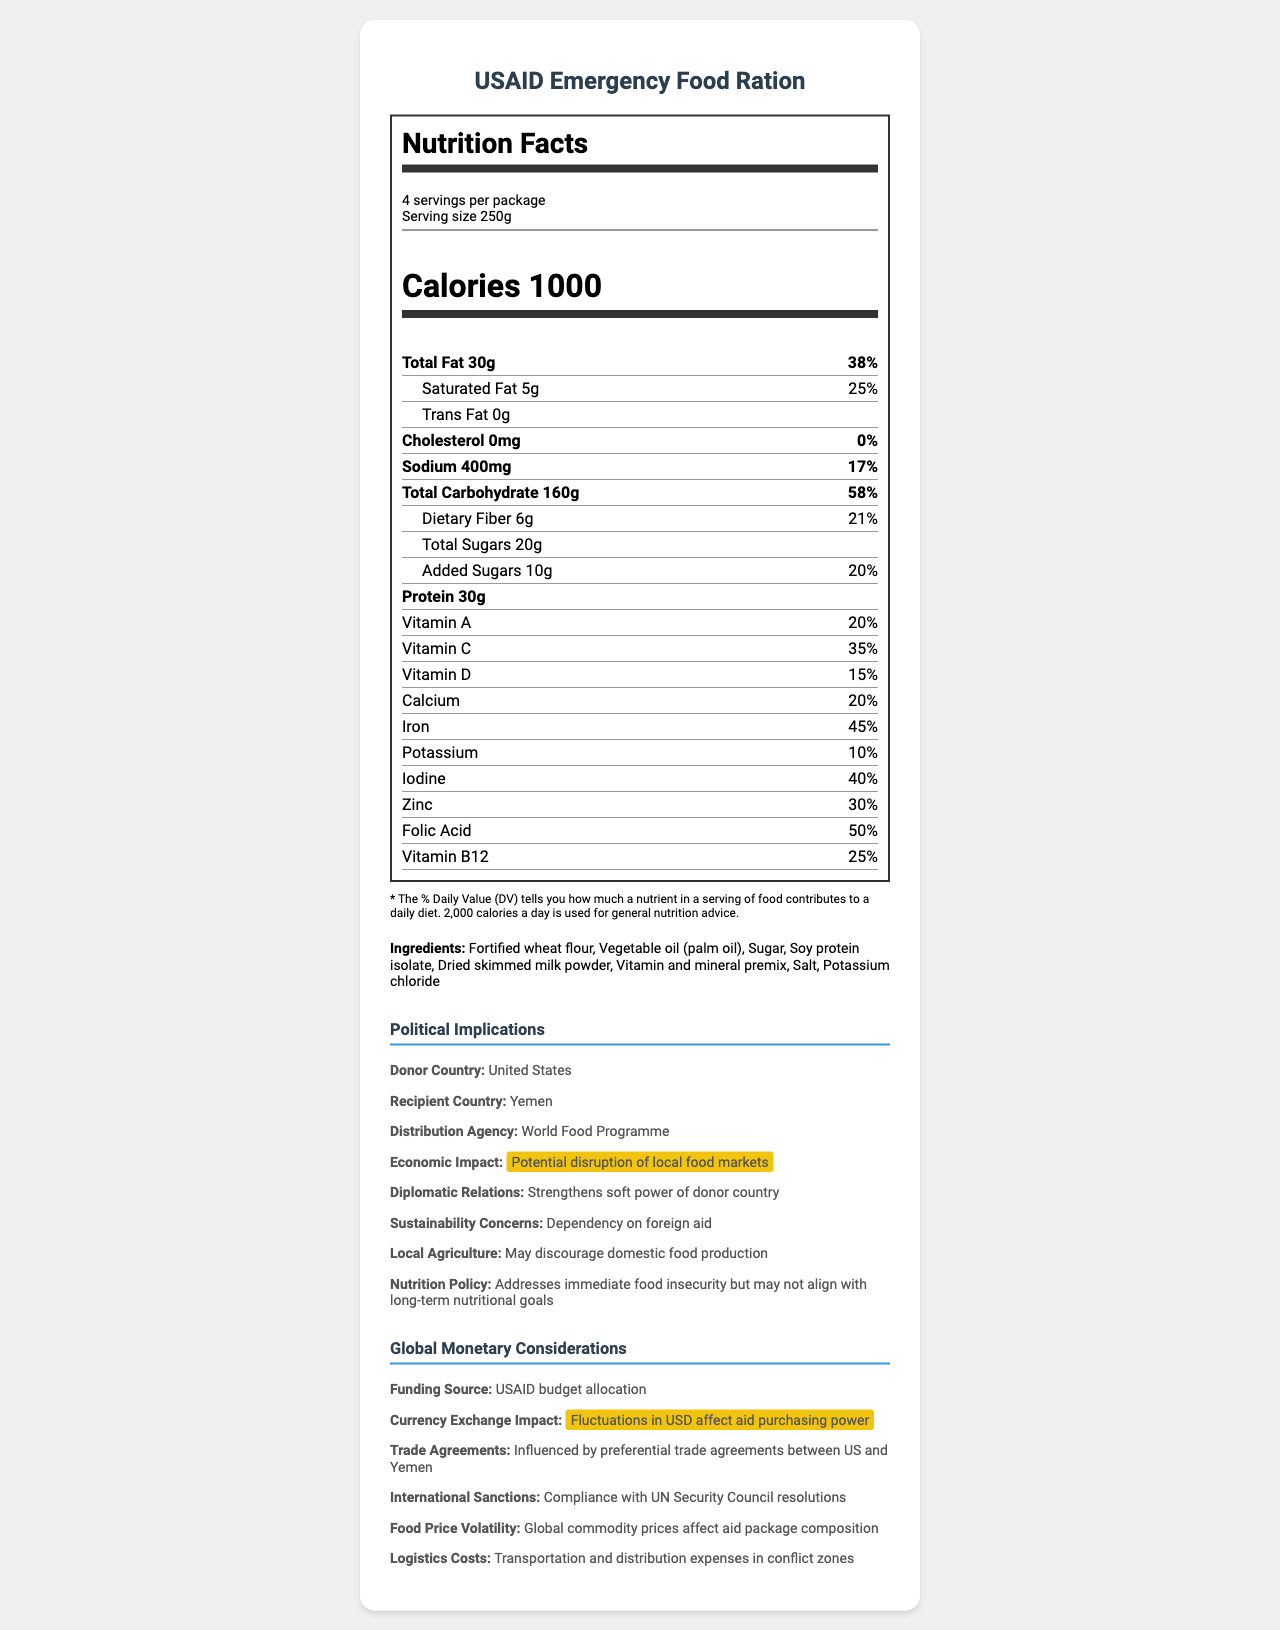what is the serving size of the food aid package? The serving size is explicitly stated as 250g.
Answer: 250g how many servings are there per package? The document specifies that there are 4 servings per package.
Answer: 4 how many grams of total fat are in one serving? The document states that there are 30g of total fat per serving.
Answer: 30g what percentage of the daily value is provided by the calcium in one serving? The document lists calcium as providing 20% of the daily value per serving.
Answer: 20% how many grams of protein are there in one serving? The document indicates that there are 30g of protein per serving.
Answer: 30g what are the potential economic impacts of this food aid package? A. Enhances local food markets B. Potential disruption of local food markets C. No effect on local food markets The document states that the economic impact could be a potential disruption of local food markets.
Answer: B how could the food aid package affect diplomatic relations between the donor and recipient countries? A. No impact B. Weakens diplomatic relations C. Strengthens soft power of donor country The document explains that the food aid package strengthens the soft power of the donor country.
Answer: C which organization is distributing the food aid? The document mentions that the distribution agency is the World Food Programme.
Answer: World Food Programme is the food aid package compliant with international sanctions? The document states that the food aid package is in compliance with UN Security Council resolutions.
Answer: Yes what is the main idea of the document? The document contains comprehensive information on the nutrition profile and the broader political and economic contexts.
Answer: The document provides detailed nutrition facts about the USAID Emergency Food Ration, including serving size, calories, and micronutrient content. It also discusses the political and economic implications of distributing this food aid package to Yemen by the World Food Programme, funded by USAID. what is the exact amount of vitamin C provided per serving? The document only provides the percentage of the daily value (35%) for vitamin C, not the exact amount.
Answer: Cannot be determined 